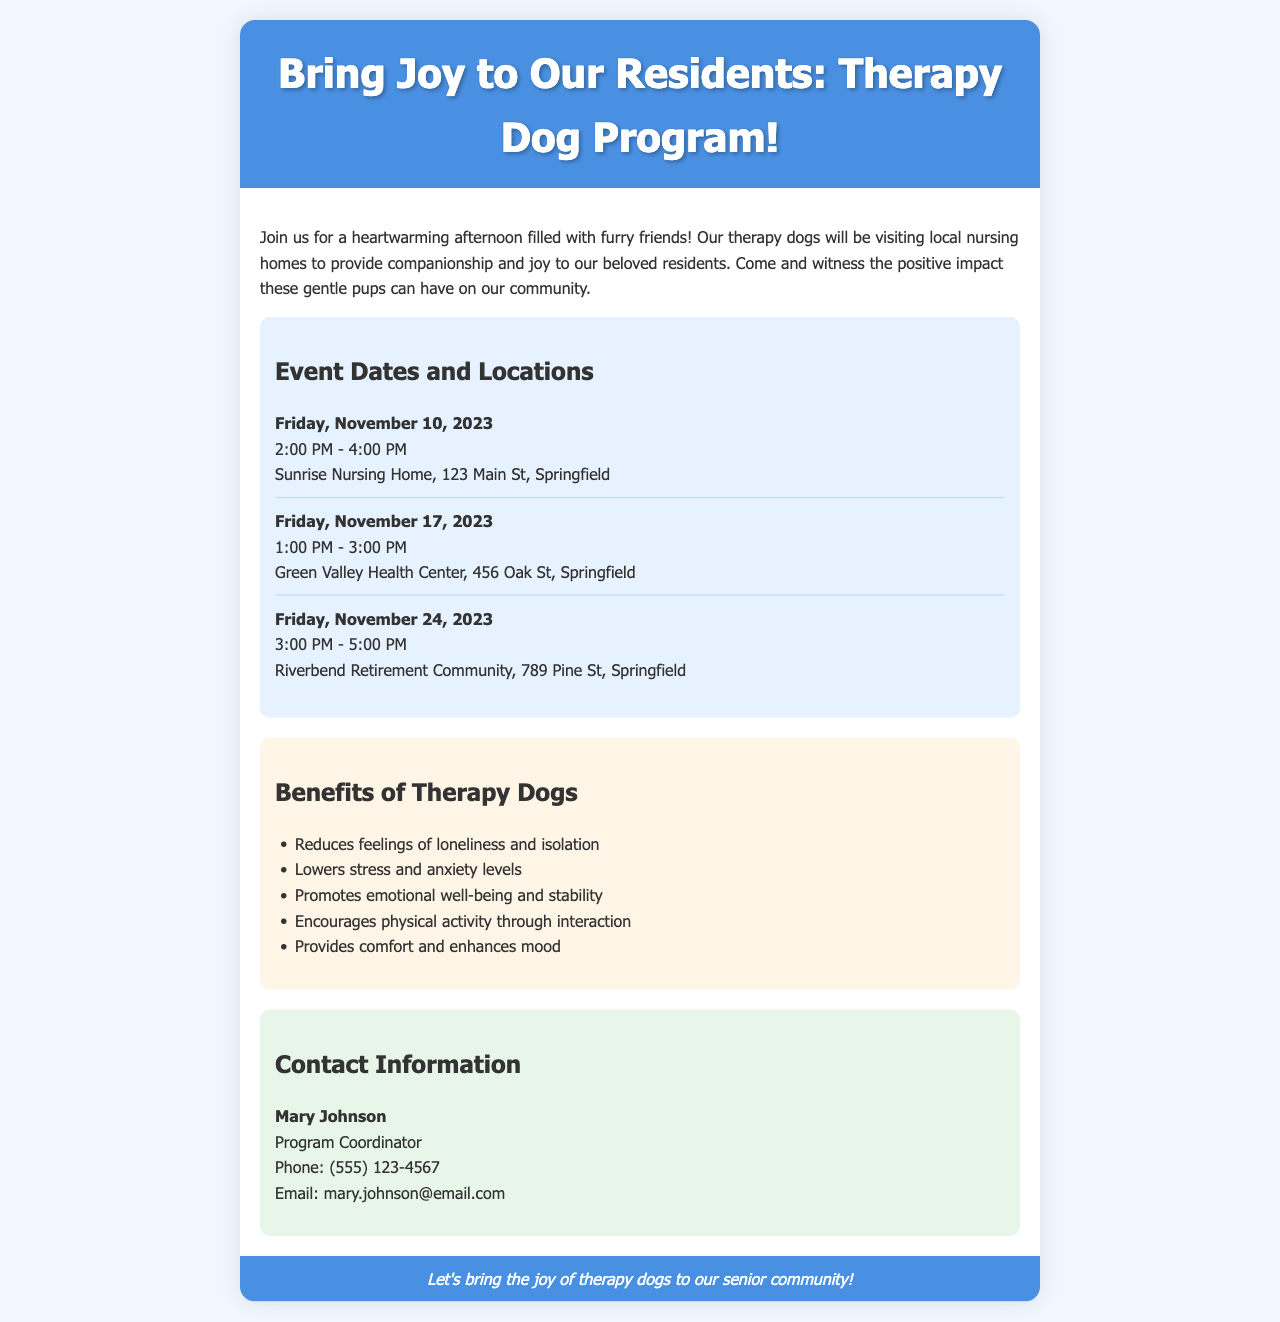What is the first event date? The first event date mentioned in the document is the first event listed under "Event Dates and Locations".
Answer: Friday, November 10, 2023 What is the location for the event on November 17? The location for the event on November 17 is found in the corresponding event date section.
Answer: Green Valley Health Center, 456 Oak St, Springfield How many benefits of therapy dogs are listed? The number of benefits listed can be counted in the "Benefits of Therapy Dogs" section.
Answer: Five Who is the Program Coordinator? The Program Coordinator's name is provided in the "Contact Information" section of the document.
Answer: Mary Johnson What time does the event on November 24 start? The start time for the event on November 24 is noted in the same section where event dates and times are provided.
Answer: 3:00 PM What is one benefit of therapy dogs mentioned? The benefits can be retrieved by looking at the bulleted list under the corresponding section.
Answer: Reduces feelings of loneliness and isolation What is the phone number for inquiries? The phone number is outlined in the contact information provided at the end of the document.
Answer: (555) 123-4567 What color is used for the header background? The color for the header background can be identified within the styles specified for the header.
Answer: #4a90e2 